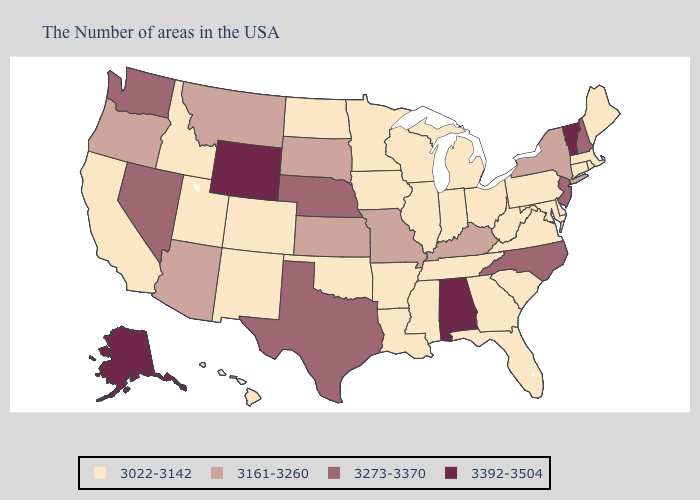What is the value of Connecticut?
Short answer required. 3022-3142. What is the lowest value in states that border Minnesota?
Quick response, please. 3022-3142. Name the states that have a value in the range 3273-3370?
Give a very brief answer. New Hampshire, New Jersey, North Carolina, Nebraska, Texas, Nevada, Washington. Name the states that have a value in the range 3392-3504?
Write a very short answer. Vermont, Alabama, Wyoming, Alaska. Among the states that border Oklahoma , does New Mexico have the highest value?
Keep it brief. No. Which states hav the highest value in the MidWest?
Write a very short answer. Nebraska. Among the states that border Ohio , which have the highest value?
Quick response, please. Kentucky. Does Alaska have the highest value in the West?
Write a very short answer. Yes. What is the value of Nevada?
Be succinct. 3273-3370. What is the value of Vermont?
Write a very short answer. 3392-3504. What is the value of Oregon?
Keep it brief. 3161-3260. Name the states that have a value in the range 3273-3370?
Be succinct. New Hampshire, New Jersey, North Carolina, Nebraska, Texas, Nevada, Washington. Name the states that have a value in the range 3161-3260?
Answer briefly. New York, Kentucky, Missouri, Kansas, South Dakota, Montana, Arizona, Oregon. 